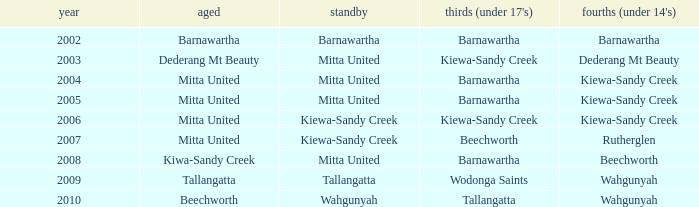Which senior individuals have a year prior to 2007, are in the under 14's category of kiewa-sandy creek, and have a reserve in mitta united? Mitta United, Mitta United. 